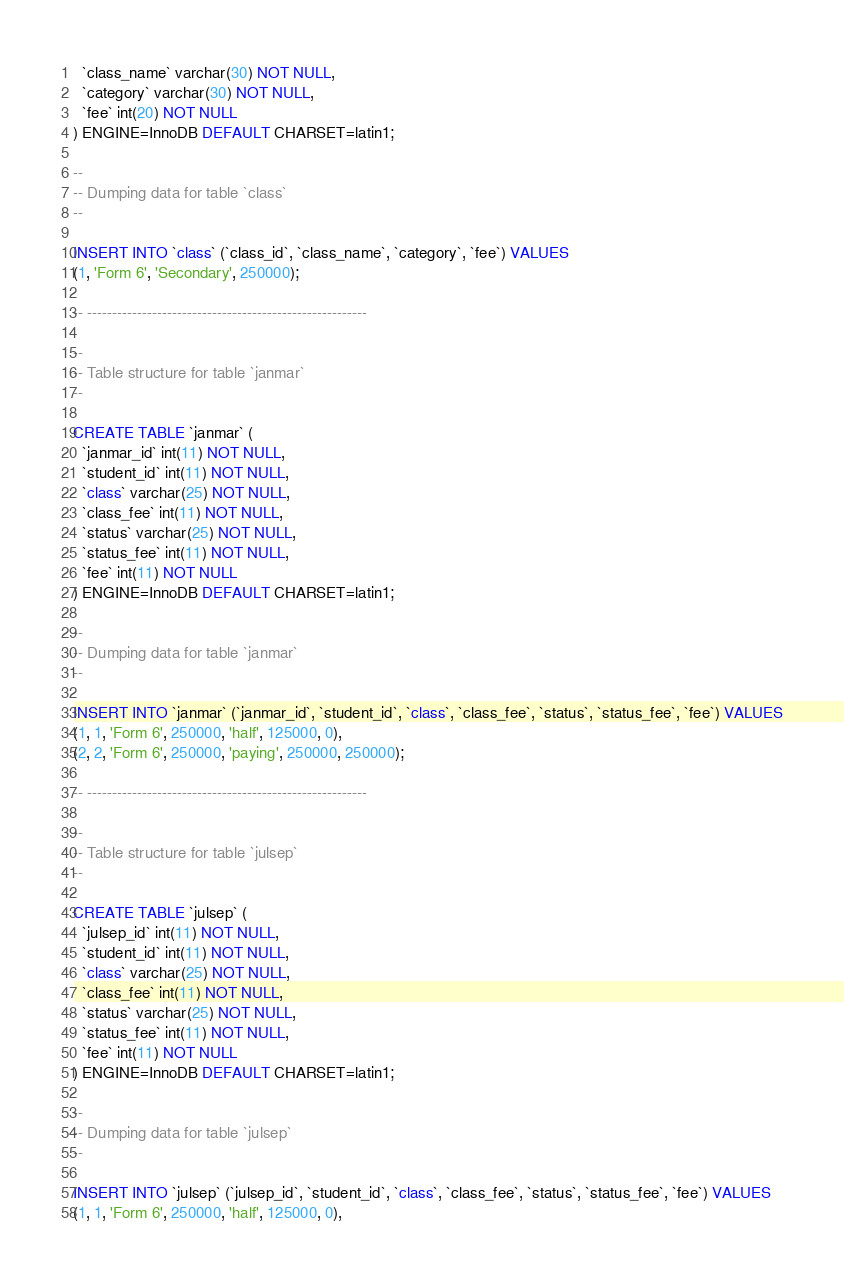<code> <loc_0><loc_0><loc_500><loc_500><_SQL_>  `class_name` varchar(30) NOT NULL,
  `category` varchar(30) NOT NULL,
  `fee` int(20) NOT NULL
) ENGINE=InnoDB DEFAULT CHARSET=latin1;

--
-- Dumping data for table `class`
--

INSERT INTO `class` (`class_id`, `class_name`, `category`, `fee`) VALUES
(1, 'Form 6', 'Secondary', 250000);

-- --------------------------------------------------------

--
-- Table structure for table `janmar`
--

CREATE TABLE `janmar` (
  `janmar_id` int(11) NOT NULL,
  `student_id` int(11) NOT NULL,
  `class` varchar(25) NOT NULL,
  `class_fee` int(11) NOT NULL,
  `status` varchar(25) NOT NULL,
  `status_fee` int(11) NOT NULL,
  `fee` int(11) NOT NULL
) ENGINE=InnoDB DEFAULT CHARSET=latin1;

--
-- Dumping data for table `janmar`
--

INSERT INTO `janmar` (`janmar_id`, `student_id`, `class`, `class_fee`, `status`, `status_fee`, `fee`) VALUES
(1, 1, 'Form 6', 250000, 'half', 125000, 0),
(2, 2, 'Form 6', 250000, 'paying', 250000, 250000);

-- --------------------------------------------------------

--
-- Table structure for table `julsep`
--

CREATE TABLE `julsep` (
  `julsep_id` int(11) NOT NULL,
  `student_id` int(11) NOT NULL,
  `class` varchar(25) NOT NULL,
  `class_fee` int(11) NOT NULL,
  `status` varchar(25) NOT NULL,
  `status_fee` int(11) NOT NULL,
  `fee` int(11) NOT NULL
) ENGINE=InnoDB DEFAULT CHARSET=latin1;

--
-- Dumping data for table `julsep`
--

INSERT INTO `julsep` (`julsep_id`, `student_id`, `class`, `class_fee`, `status`, `status_fee`, `fee`) VALUES
(1, 1, 'Form 6', 250000, 'half', 125000, 0),</code> 